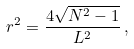<formula> <loc_0><loc_0><loc_500><loc_500>r ^ { 2 } = \frac { 4 \sqrt { N ^ { 2 } - 1 } } { L ^ { 2 } } \, ,</formula> 